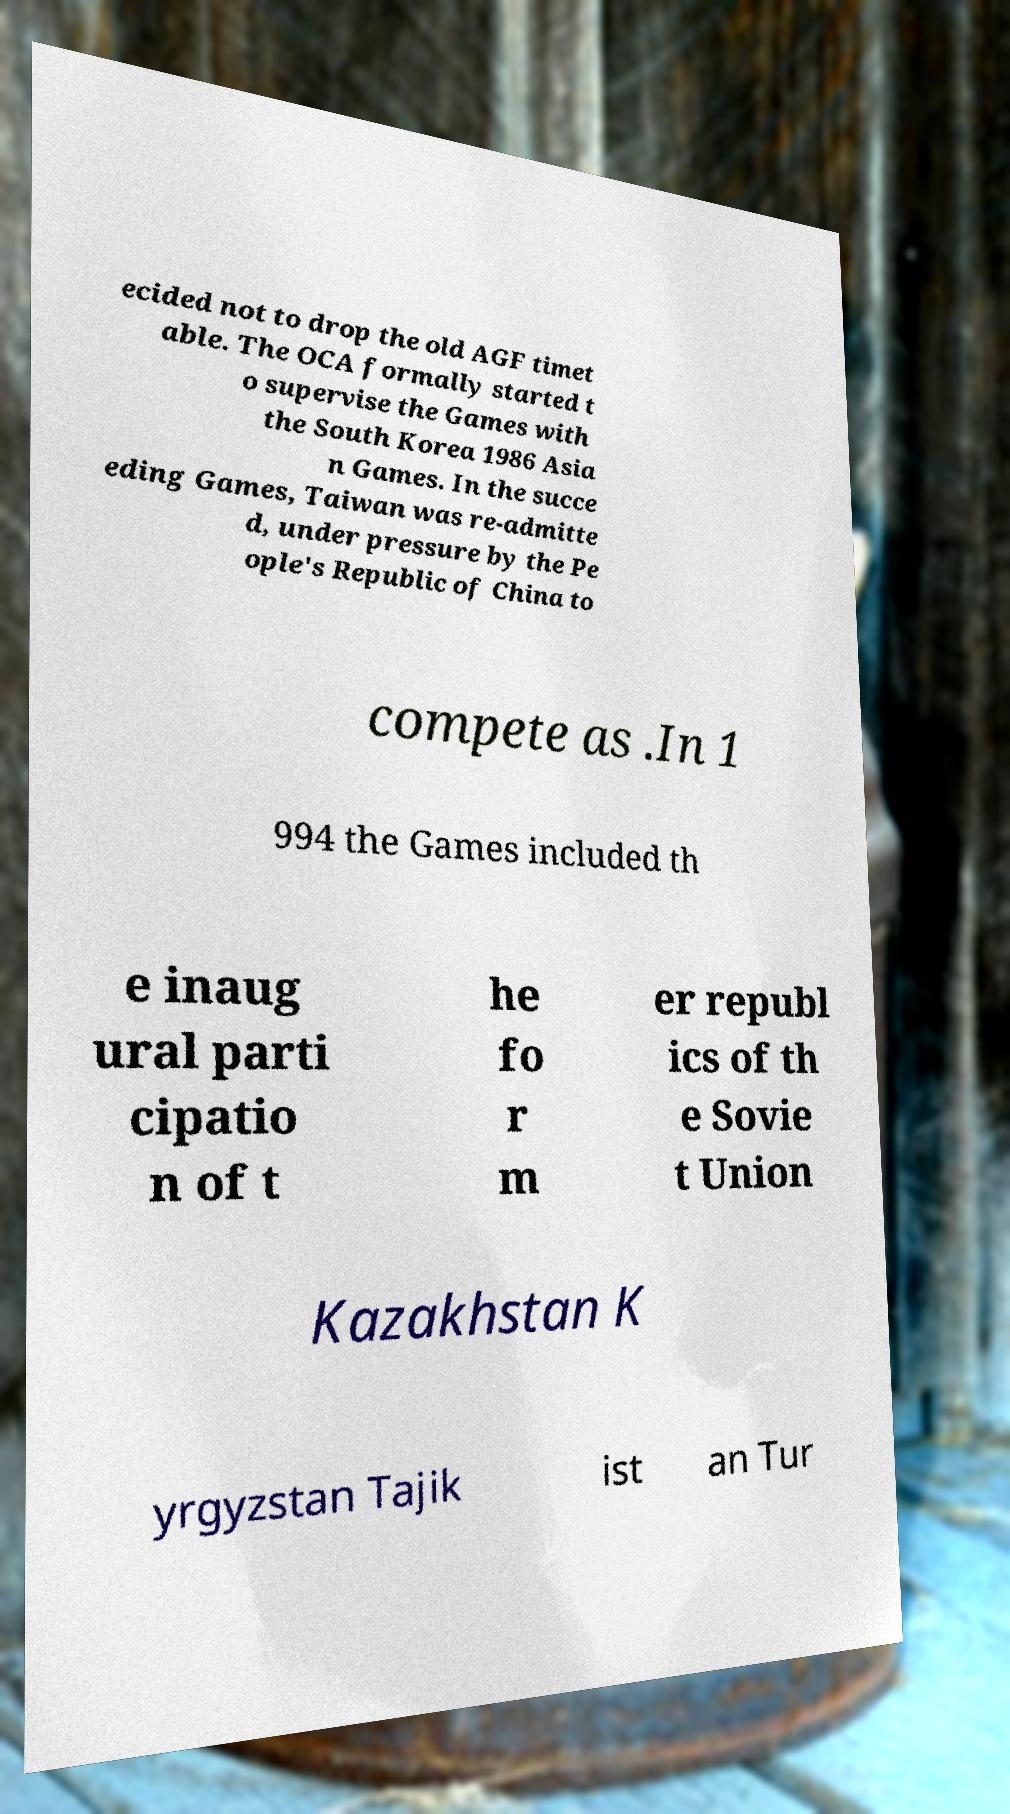There's text embedded in this image that I need extracted. Can you transcribe it verbatim? ecided not to drop the old AGF timet able. The OCA formally started t o supervise the Games with the South Korea 1986 Asia n Games. In the succe eding Games, Taiwan was re-admitte d, under pressure by the Pe ople's Republic of China to compete as .In 1 994 the Games included th e inaug ural parti cipatio n of t he fo r m er republ ics of th e Sovie t Union Kazakhstan K yrgyzstan Tajik ist an Tur 